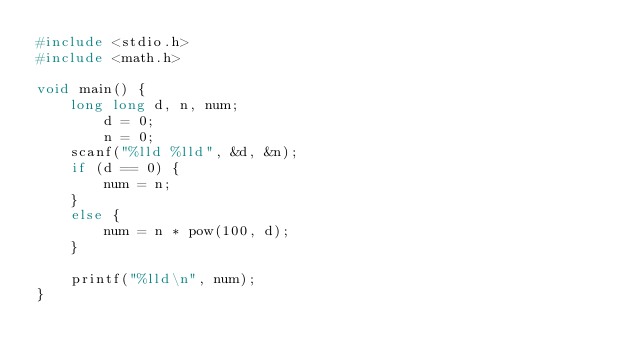<code> <loc_0><loc_0><loc_500><loc_500><_C_>#include <stdio.h>
#include <math.h>

void main() {
	long long d, n, num;
        d = 0;
        n = 0;
	scanf("%lld %lld", &d, &n);
	if (d == 0) {
		num = n;
	}
	else {
		num = n * pow(100, d);
	}
	
	printf("%lld\n", num);
}
</code> 